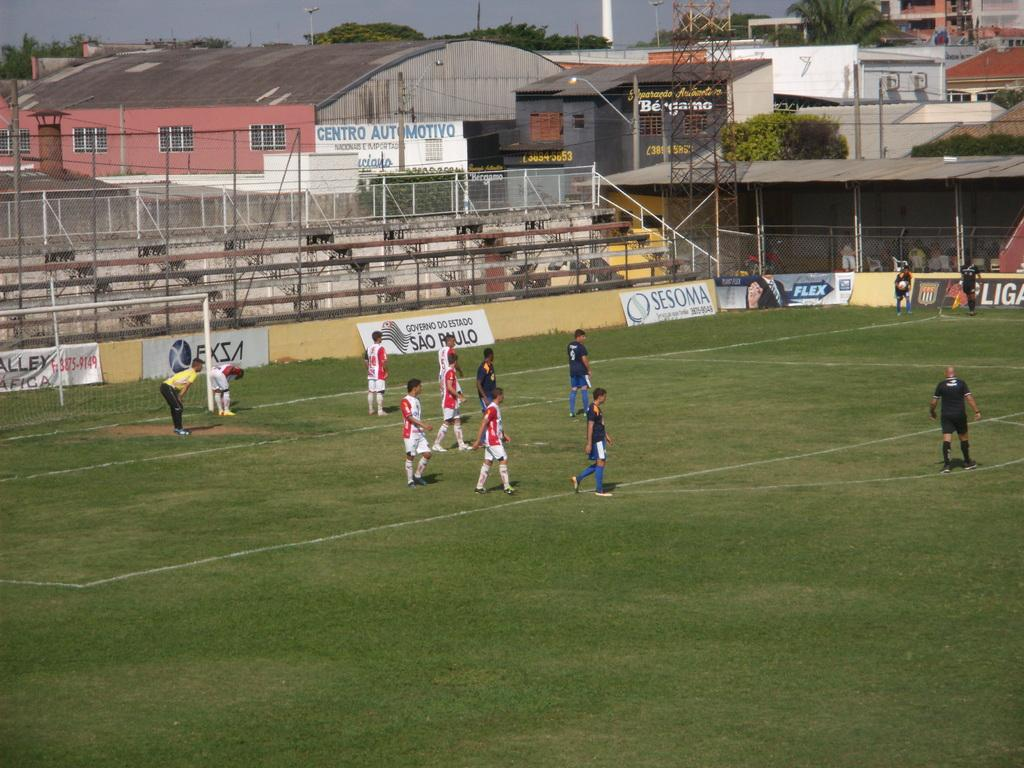<image>
Provide a brief description of the given image. Young boys play soccer on a field sponsored by Sesoma and Flex. 